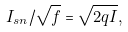Convert formula to latex. <formula><loc_0><loc_0><loc_500><loc_500>I _ { s n } / \sqrt { f } = \sqrt { 2 q I } ,</formula> 